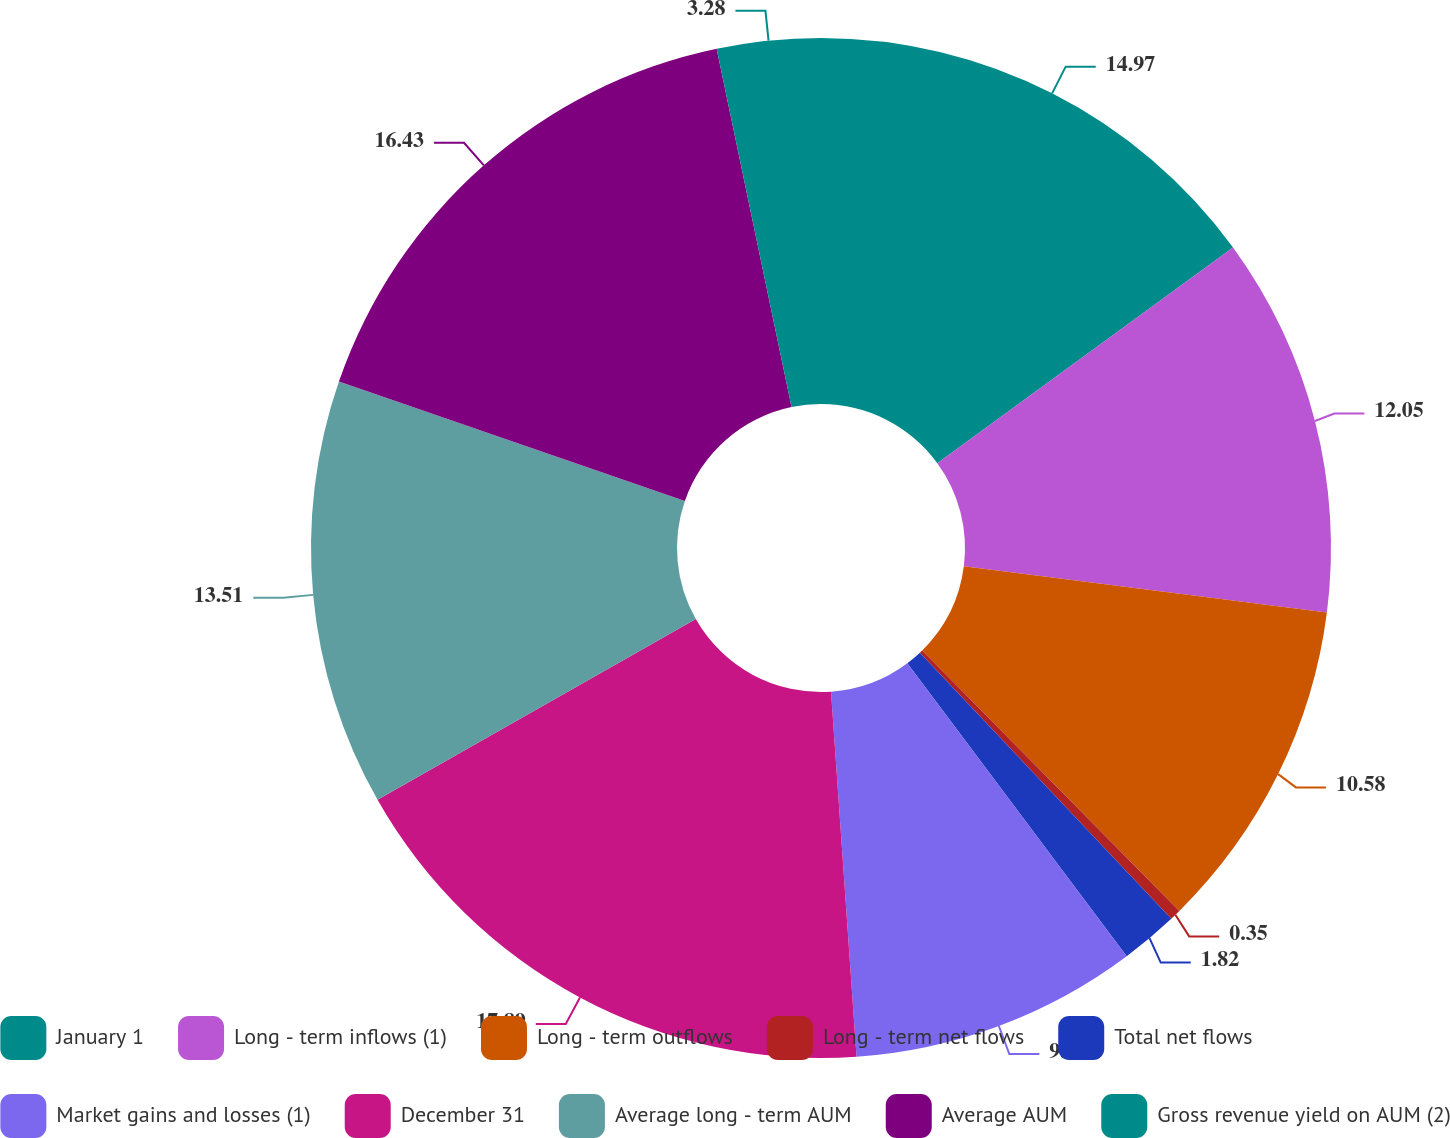Convert chart. <chart><loc_0><loc_0><loc_500><loc_500><pie_chart><fcel>January 1<fcel>Long - term inflows (1)<fcel>Long - term outflows<fcel>Long - term net flows<fcel>Total net flows<fcel>Market gains and losses (1)<fcel>December 31<fcel>Average long - term AUM<fcel>Average AUM<fcel>Gross revenue yield on AUM (2)<nl><fcel>14.97%<fcel>12.05%<fcel>10.58%<fcel>0.35%<fcel>1.82%<fcel>9.12%<fcel>17.89%<fcel>13.51%<fcel>16.43%<fcel>3.28%<nl></chart> 